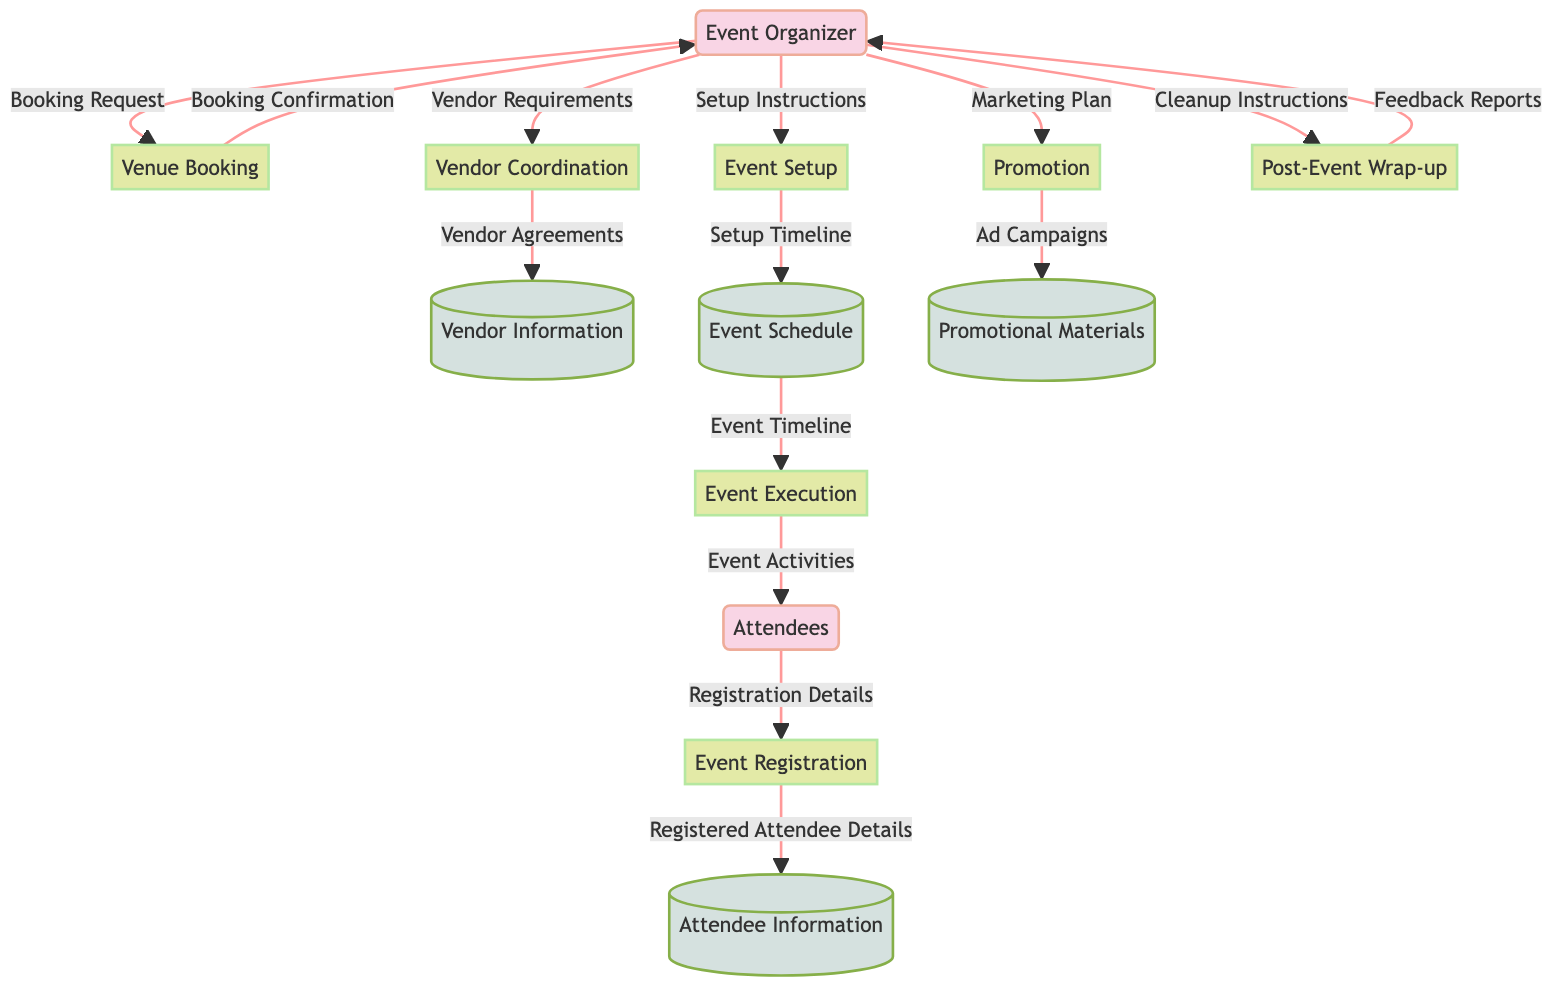What is the first process in the event management flow? Looking at the diagram, the first process that connects an external entity (Attendees) is "Event Registration". This process serves as the entry point for attendees to sign up for the event.
Answer: Event Registration How many external entities are there in the diagram? The diagram lists two external entities: "Event Organizer" and "Attendees". By counting them, we find there are a total of two external entities.
Answer: 2 What type of information does the "Attendee Information" datastore hold? The description of the "Attendee Information" datastore indicates it contains "registration details of attendees". Thus, it stores relevant data related to attendees' registrations.
Answer: Registration details Which process follows "Promotion"? Following the flow from the "Promotion" process, the next process is "Event Setup". This sequencing indicates that after promoting the event, preparations need to be made for the actual setup.
Answer: Event Setup What is the final process in the event management flow? Tracing through the diagram, the last process that takes place after the event is "Post-Event Wrap-up". This step involves cleanup and gathering feedback from attendees.
Answer: Post-Event Wrap-up What data flows from "Event Registration" to "Attendee Information"? The data that flows from "Event Registration" to "Attendee Information" is described as "Registered Attendee Details". This indicates that the registered details from the attendees are stored in this datastore.
Answer: Registered Attendee Details How does the "Event Organizer" contribute to "Vendor Coordination"? The "Event Organizer" provides the "Vendor Requirements" to the "Vendor Coordination" process, which is crucial for arranging the vendors' participation in the event.
Answer: Vendor Requirements From which process does "Event Timeline" flow? The "Event Timeline" flows from the "Event Schedule". This means that the planned activities and timelines are established before the execution of the event and are essential to its organization.
Answer: Event Schedule What relationship does "Venue Booking" have with "Event Organizer"? The relationship indicates that the "Event Organizer" sends a "Booking Request" to "Venue Booking" and, in return, receives a "Booking Confirmation" after the venue is successfully booked.
Answer: Booking Request and Booking Confirmation 